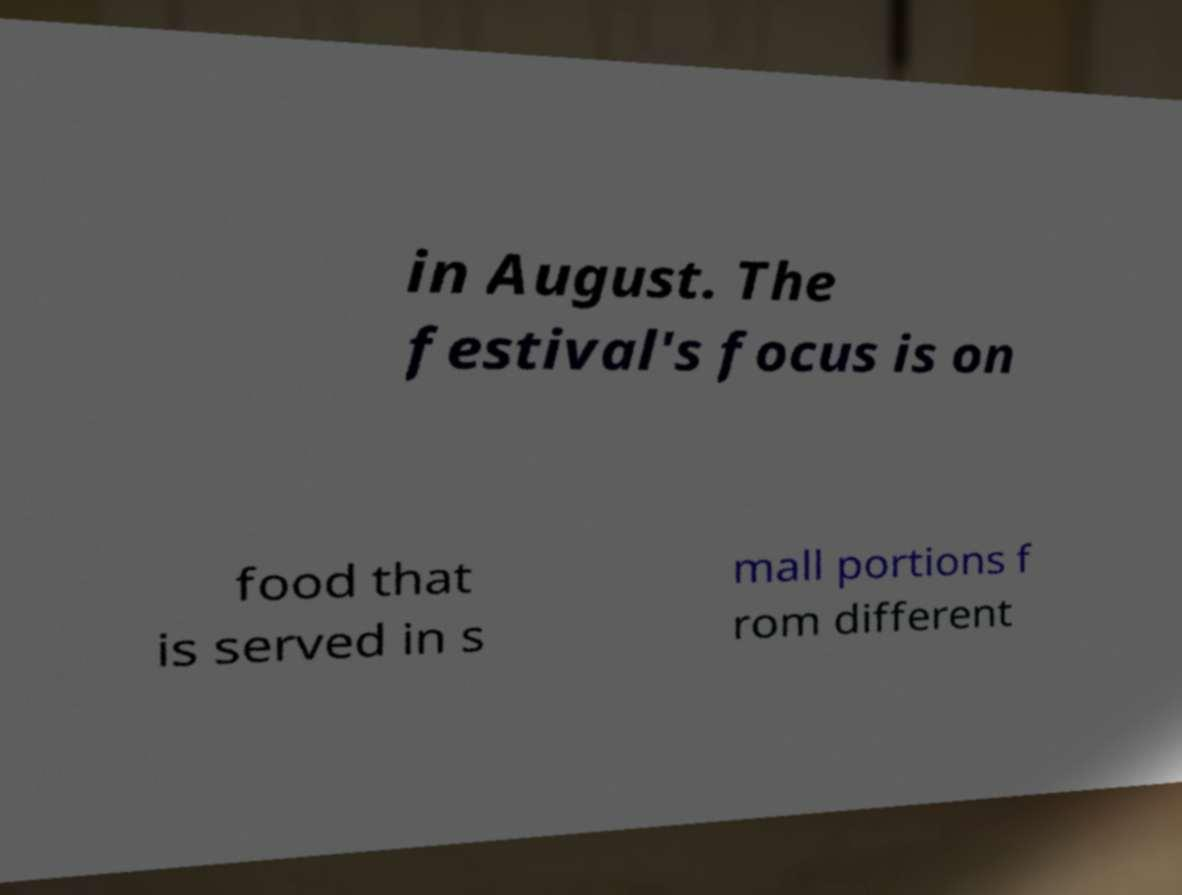I need the written content from this picture converted into text. Can you do that? in August. The festival's focus is on food that is served in s mall portions f rom different 